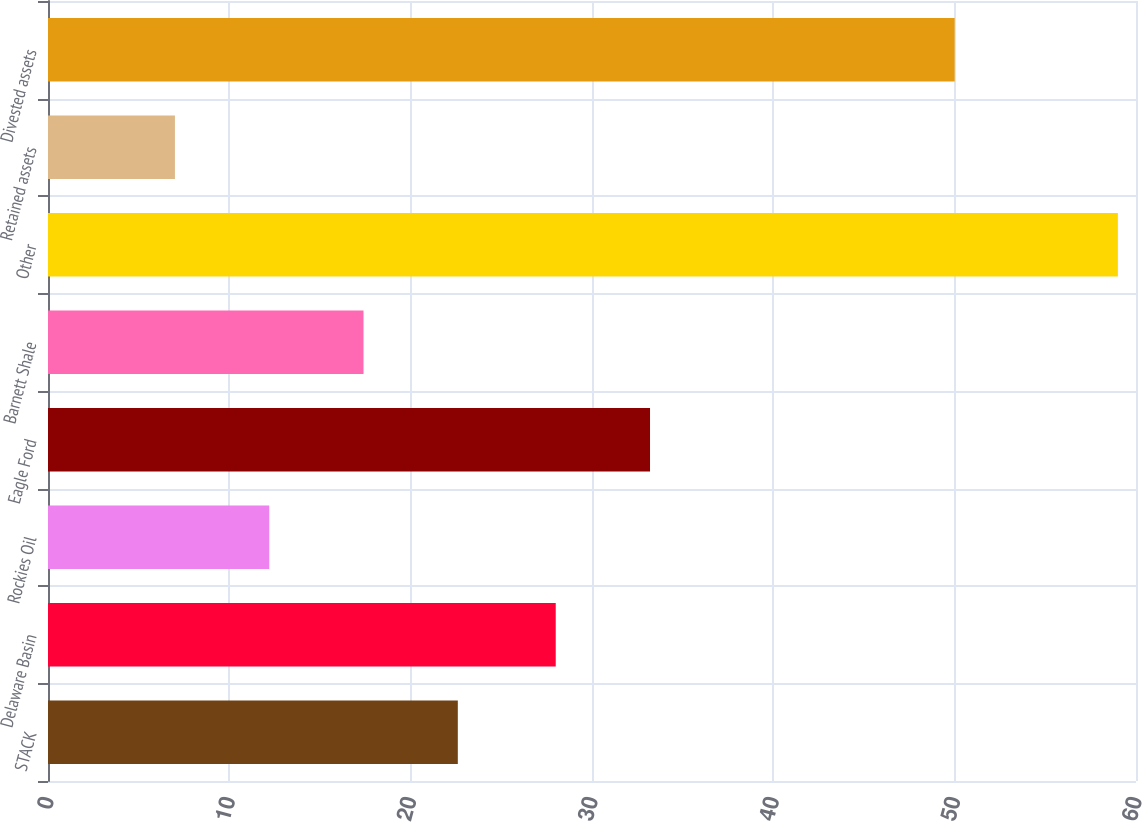Convert chart. <chart><loc_0><loc_0><loc_500><loc_500><bar_chart><fcel>STACK<fcel>Delaware Basin<fcel>Rockies Oil<fcel>Eagle Ford<fcel>Barnett Shale<fcel>Other<fcel>Retained assets<fcel>Divested assets<nl><fcel>22.6<fcel>28<fcel>12.2<fcel>33.2<fcel>17.4<fcel>59<fcel>7<fcel>50<nl></chart> 